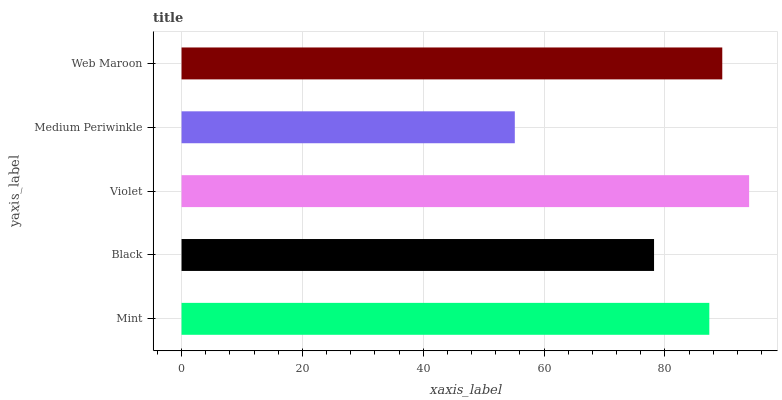Is Medium Periwinkle the minimum?
Answer yes or no. Yes. Is Violet the maximum?
Answer yes or no. Yes. Is Black the minimum?
Answer yes or no. No. Is Black the maximum?
Answer yes or no. No. Is Mint greater than Black?
Answer yes or no. Yes. Is Black less than Mint?
Answer yes or no. Yes. Is Black greater than Mint?
Answer yes or no. No. Is Mint less than Black?
Answer yes or no. No. Is Mint the high median?
Answer yes or no. Yes. Is Mint the low median?
Answer yes or no. Yes. Is Black the high median?
Answer yes or no. No. Is Web Maroon the low median?
Answer yes or no. No. 